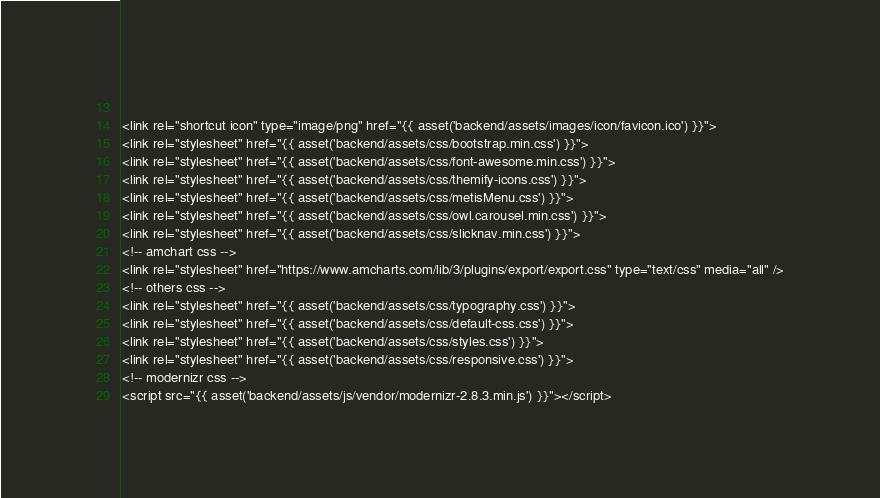<code> <loc_0><loc_0><loc_500><loc_500><_PHP_>  
<link rel="shortcut icon" type="image/png" href="{{ asset('backend/assets/images/icon/favicon.ico') }}">
<link rel="stylesheet" href="{{ asset('backend/assets/css/bootstrap.min.css') }}">
<link rel="stylesheet" href="{{ asset('backend/assets/css/font-awesome.min.css') }}">
<link rel="stylesheet" href="{{ asset('backend/assets/css/themify-icons.css') }}">
<link rel="stylesheet" href="{{ asset('backend/assets/css/metisMenu.css') }}">
<link rel="stylesheet" href="{{ asset('backend/assets/css/owl.carousel.min.css') }}">
<link rel="stylesheet" href="{{ asset('backend/assets/css/slicknav.min.css') }}">
<!-- amchart css -->
<link rel="stylesheet" href="https://www.amcharts.com/lib/3/plugins/export/export.css" type="text/css" media="all" />
<!-- others css -->
<link rel="stylesheet" href="{{ asset('backend/assets/css/typography.css') }}">
<link rel="stylesheet" href="{{ asset('backend/assets/css/default-css.css') }}">
<link rel="stylesheet" href="{{ asset('backend/assets/css/styles.css') }}">
<link rel="stylesheet" href="{{ asset('backend/assets/css/responsive.css') }}">
<!-- modernizr css -->
<script src="{{ asset('backend/assets/js/vendor/modernizr-2.8.3.min.js') }}"></script></code> 